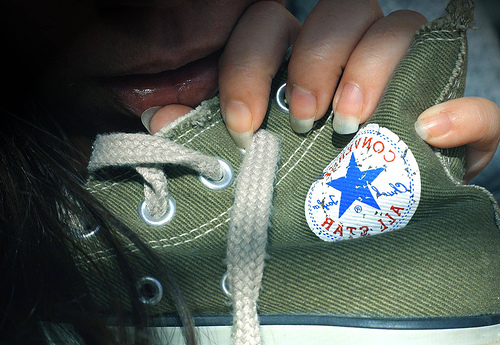<image>
Is the woman on the shoe? Yes. Looking at the image, I can see the woman is positioned on top of the shoe, with the shoe providing support. 